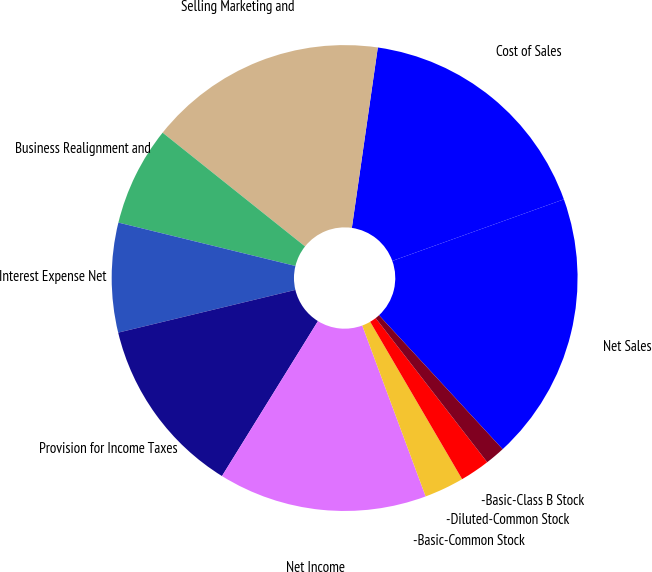Convert chart to OTSL. <chart><loc_0><loc_0><loc_500><loc_500><pie_chart><fcel>Net Sales<fcel>Cost of Sales<fcel>Selling Marketing and<fcel>Business Realignment and<fcel>Interest Expense Net<fcel>Provision for Income Taxes<fcel>Net Income<fcel>-Basic-Common Stock<fcel>-Diluted-Common Stock<fcel>-Basic-Class B Stock<nl><fcel>18.62%<fcel>17.24%<fcel>16.55%<fcel>6.9%<fcel>7.59%<fcel>12.41%<fcel>14.48%<fcel>2.76%<fcel>2.07%<fcel>1.38%<nl></chart> 